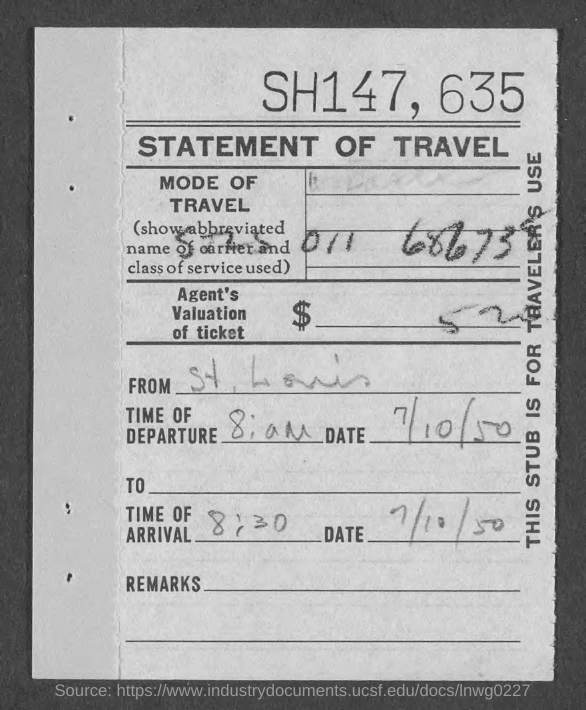What type of statement is given here?
Your answer should be very brief. STATEMENT OF TRAVEL. What is the time of arrival given in the statement?
Ensure brevity in your answer.  8:30. What is the date of departure given in the statement?
Keep it short and to the point. 7/10/50. What is the date of arrival given in the statement?
Ensure brevity in your answer.  7/10/50. 